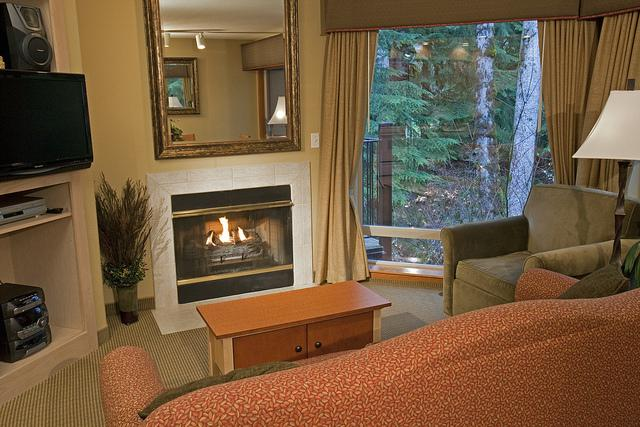What is the most likely floor level for this room? second 